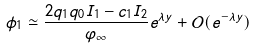<formula> <loc_0><loc_0><loc_500><loc_500>\phi _ { 1 } \simeq \frac { 2 q _ { 1 } q _ { 0 } I _ { 1 } - c _ { 1 } I _ { 2 } } { \varphi _ { \infty } } e ^ { \lambda y } + { \mathcal { O } } ( e ^ { - \lambda y } )</formula> 